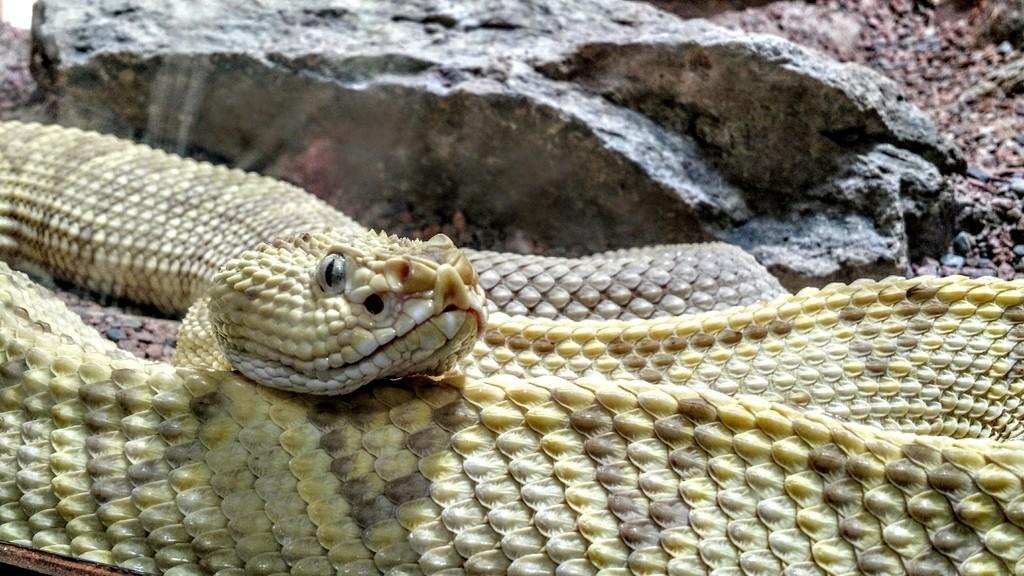What type of animal is in the image? There is a snake in the image. What else can be seen in the image besides the snake? There are rocks and stones in the image. How many cows are present in the image? There are no cows present in the image; it features a snake and rocks. What type of pest can be seen in the image? There is no pest visible in the image; it features a snake, rocks, and stones. 